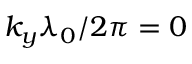Convert formula to latex. <formula><loc_0><loc_0><loc_500><loc_500>k _ { y } \lambda _ { 0 } / 2 \pi = 0</formula> 